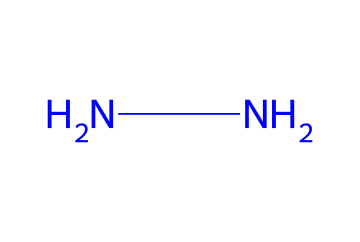What is the molecular formula of hydrazine based on its structure? The structure shows two nitrogen atoms connected by a single bond, which defines hydrazine. Each nitrogen typically has two hydrogen atoms to satisfy the tetravalent nature of carbon, but since we only have nitrogen in this case, the molecular formula is derived from counting the atoms: two nitrogen (N) and four hydrogen (H).
Answer: N2H4 How many nitrogen atoms does hydrazine contain? Inspecting the SMILES representation, "NN" indicates that there are two nitrogen atoms connected together.
Answer: 2 What type of bonding is present in hydrazine? In the structure indicated by the SMILES "NN", the two N atoms are connected by a single bond. This analysis leads us to note that all bonds between the nitrogen atoms are single bonds.
Answer: single bonds Is hydrazine a solid, liquid, or gas at room temperature? The chemical structure of hydrazine and knowledge of its properties indicate that hydrazine is typically found as a liquid at room temperature. This is due to its relatively low molecular weight and intermolecular interactions.
Answer: liquid What is the primary use of hydrazine in aerospace engineering? Hydrazine's structure and energy content make it a good propellant choice for rocket systems where it is used in various propulsion applications. This is based on its high reactivity and ability to release energy.
Answer: rocket fuel How does the structure of hydrazine influence its reactivity compared to other fuels? The presence of two nitrogen atoms in hydrazine provides unique properties such as high reactivity and stability when compared to hydrocarbon-based fuels, which typically include carbon. This is significant because nitrogen bonds are energetically favorable for certain combustion reactions useful in rocket propulsion.
Answer: high reactivity 